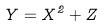Convert formula to latex. <formula><loc_0><loc_0><loc_500><loc_500>Y = X ^ { 2 } + Z</formula> 